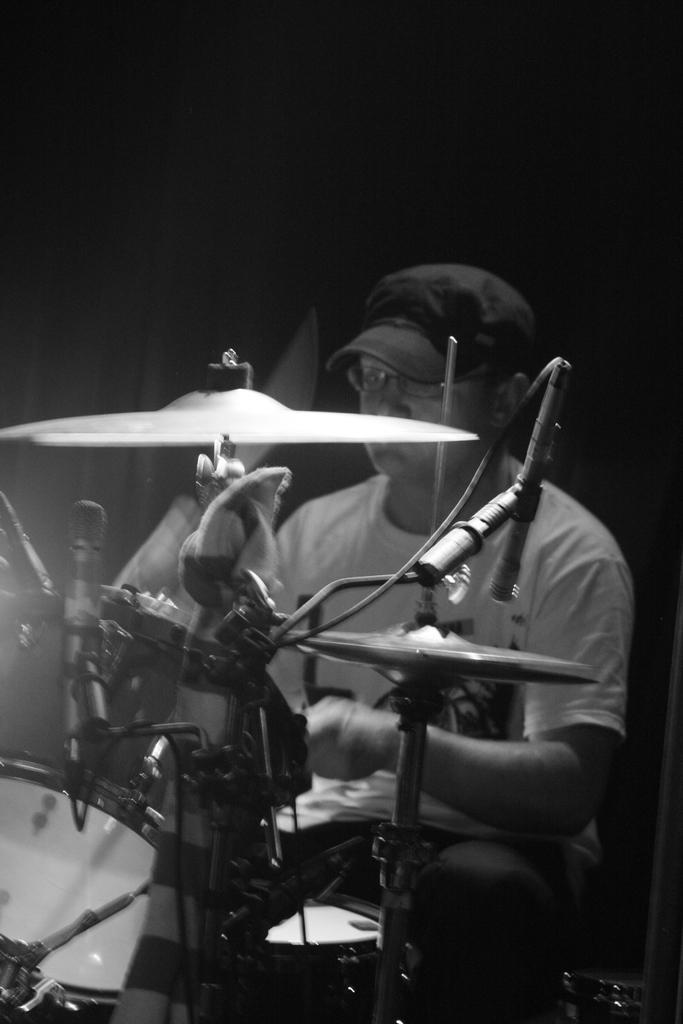Please provide a concise description of this image. In this picture I can see a man seated and playing drums and and I can see a cap on his head and I can see dark background. 